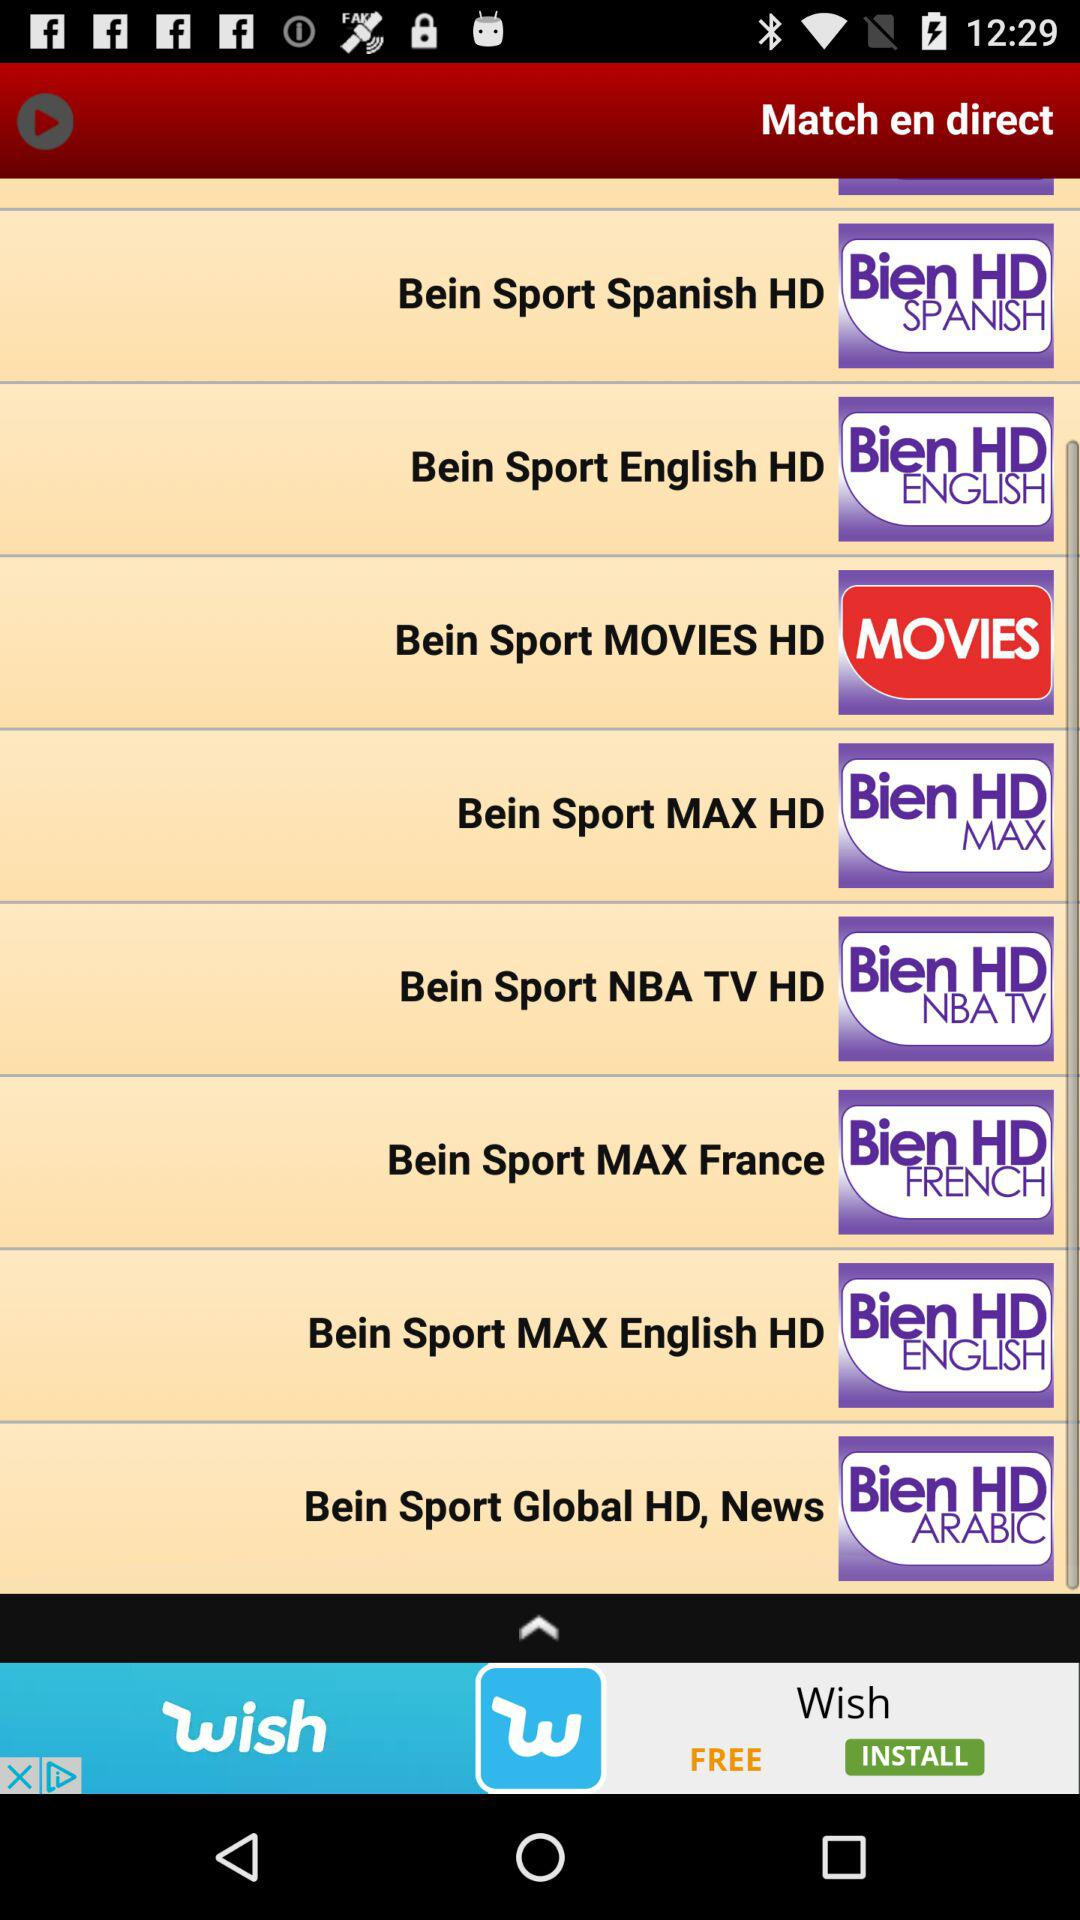What kind of content might the 'Bein Sport MOVIES HD' channel feature? The 'Bein Sport MOVIES HD' channel likely features a variety of movies, possibly with a focus on those that have a sports theme or involve sports-related narratives, presented in high definition quality. 